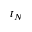<formula> <loc_0><loc_0><loc_500><loc_500>t _ { N }</formula> 